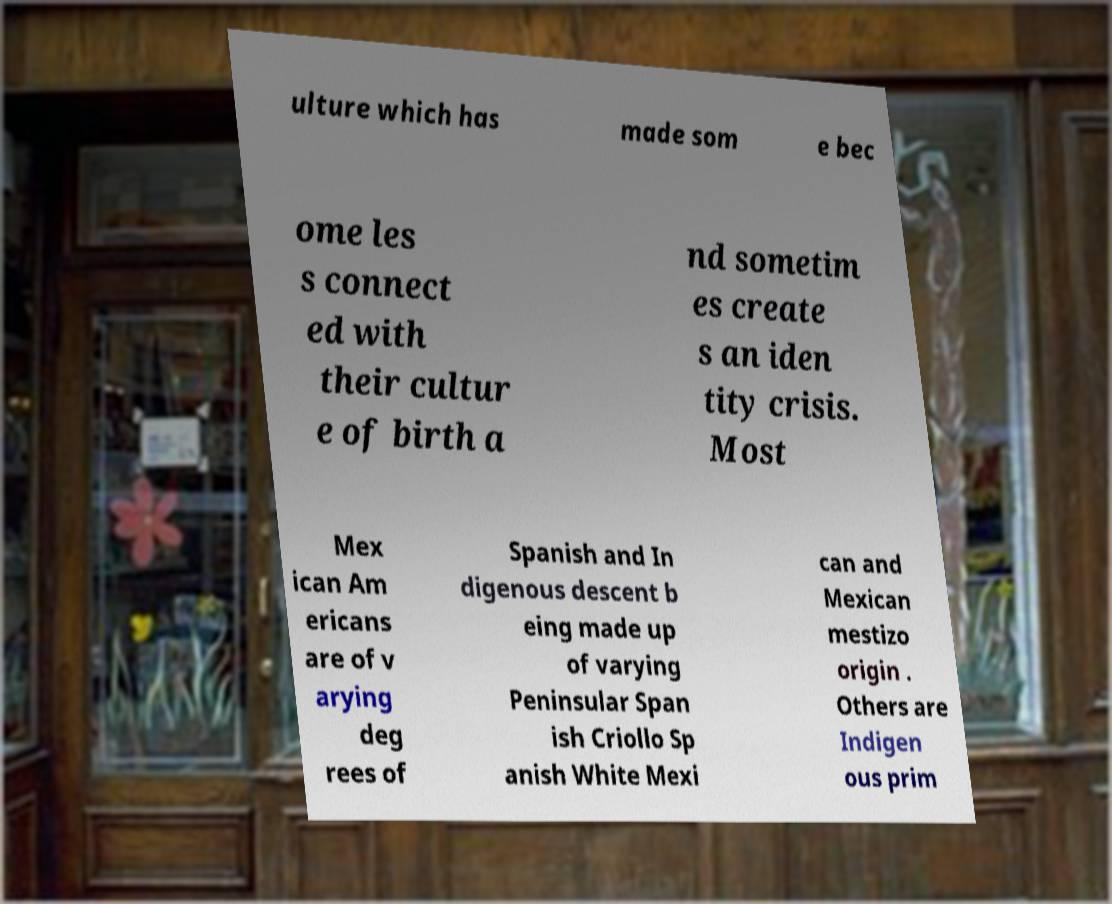Could you assist in decoding the text presented in this image and type it out clearly? ulture which has made som e bec ome les s connect ed with their cultur e of birth a nd sometim es create s an iden tity crisis. Most Mex ican Am ericans are of v arying deg rees of Spanish and In digenous descent b eing made up of varying Peninsular Span ish Criollo Sp anish White Mexi can and Mexican mestizo origin . Others are Indigen ous prim 